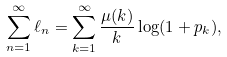<formula> <loc_0><loc_0><loc_500><loc_500>\sum _ { n = 1 } ^ { \infty } \ell _ { n } = \sum _ { k = 1 } ^ { \infty } \frac { \mu ( k ) } { k } \log ( 1 + p _ { k } ) ,</formula> 